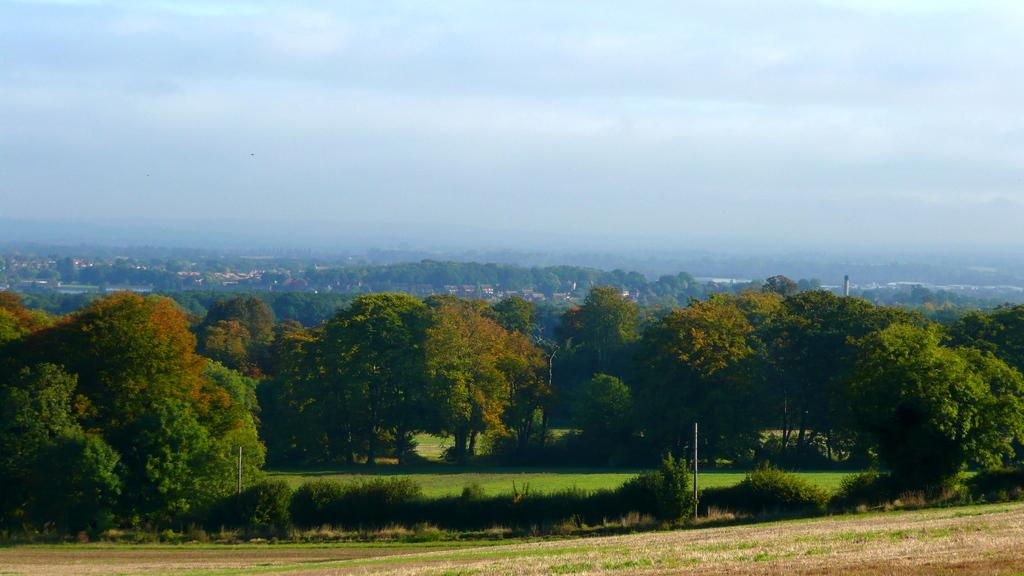What type of vegetation can be seen in the image? There are plants, trees, and grass in the image. What are the poles used for in the image? The purpose of the poles in the image is not specified, but they could be used for support or decoration. What is visible in the background of the image? The sky is visible in the background of the image. What type of silver structure can be seen in the image? There is no silver structure present in the image. How many masses are visible in the image? There is no reference to a mass in the image, so it is not possible to determine the number of masses. 